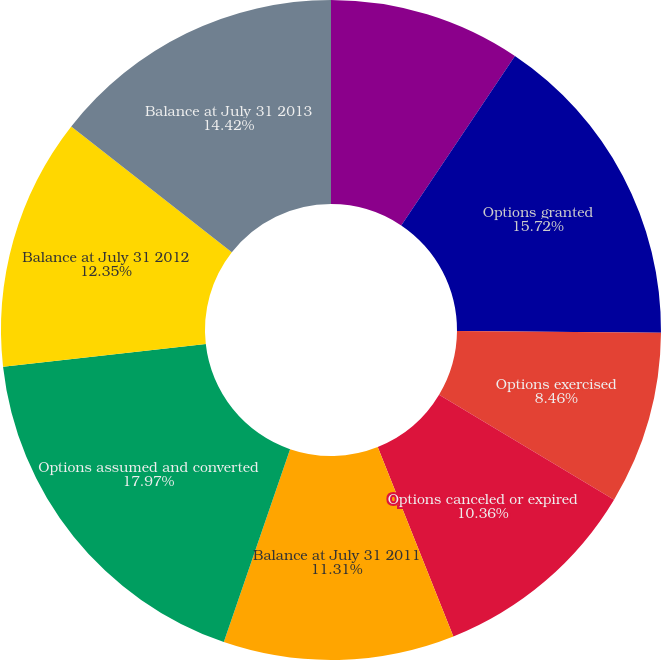Convert chart. <chart><loc_0><loc_0><loc_500><loc_500><pie_chart><fcel>Balance at July 31 2010<fcel>Options granted<fcel>Options exercised<fcel>Options canceled or expired<fcel>Balance at July 31 2011<fcel>Options assumed and converted<fcel>Balance at July 31 2012<fcel>Balance at July 31 2013<nl><fcel>9.41%<fcel>15.72%<fcel>8.46%<fcel>10.36%<fcel>11.31%<fcel>17.96%<fcel>12.35%<fcel>14.42%<nl></chart> 